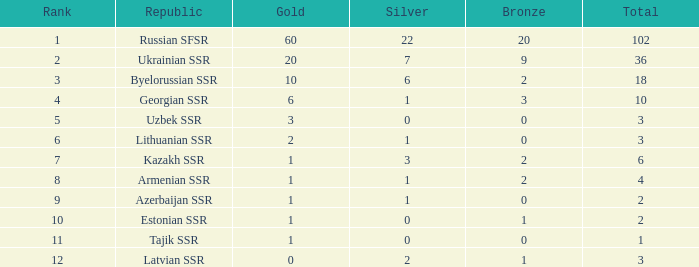What is the sum of bronzes for teams with more than 2 gold, ranked under 3, and less than 22 silver? 9.0. 